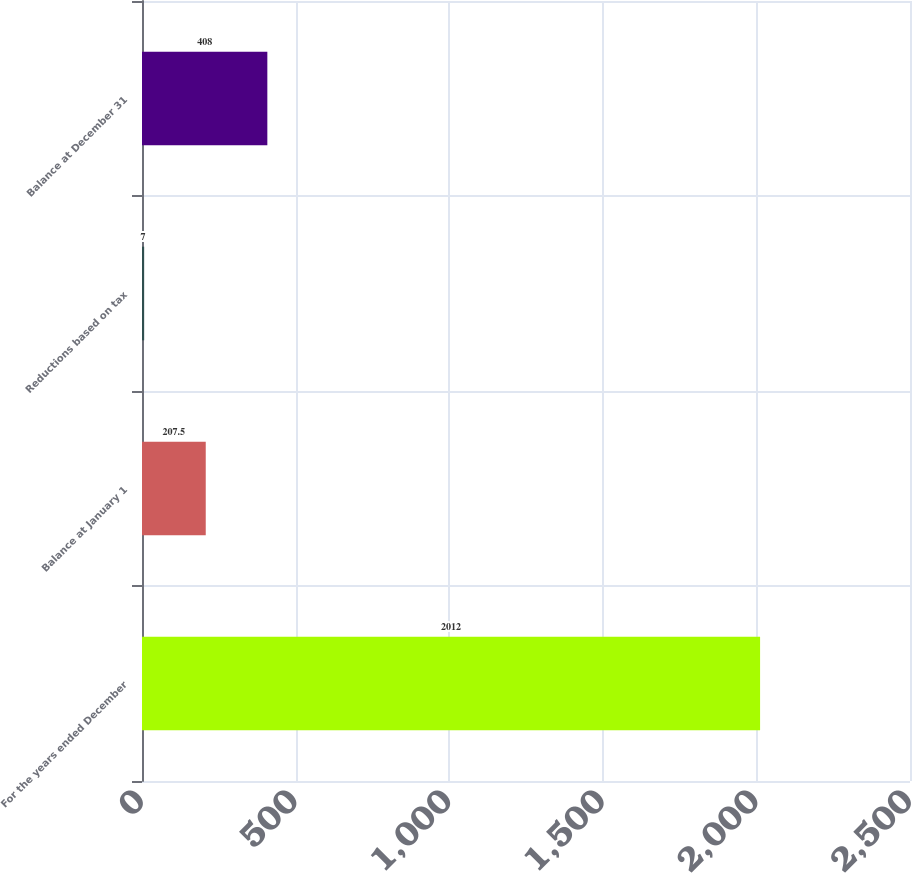Convert chart. <chart><loc_0><loc_0><loc_500><loc_500><bar_chart><fcel>For the years ended December<fcel>Balance at January 1<fcel>Reductions based on tax<fcel>Balance at December 31<nl><fcel>2012<fcel>207.5<fcel>7<fcel>408<nl></chart> 